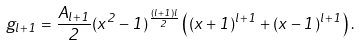Convert formula to latex. <formula><loc_0><loc_0><loc_500><loc_500>g _ { l + 1 } = \frac { A _ { l + 1 } } { 2 } ( x ^ { 2 } - 1 ) ^ { \frac { ( l + 1 ) l } { 2 } } \left ( ( x + 1 ) ^ { l + 1 } + ( x - 1 ) ^ { l + 1 } \right ) .</formula> 